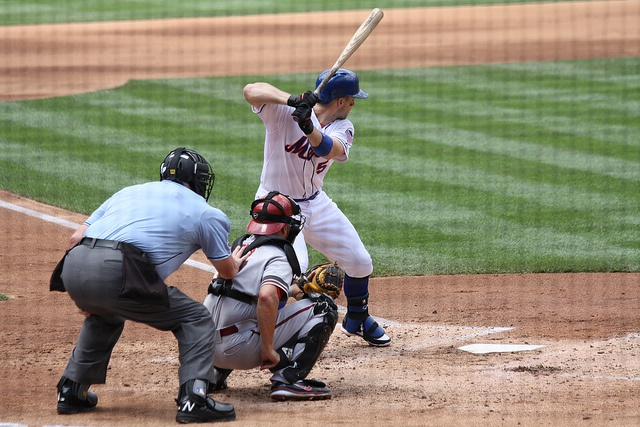Describe the objects in this image and their specific colors. I can see people in olive, black, gray, and lightblue tones, people in olive, black, gray, maroon, and darkgray tones, people in olive, darkgray, black, and lavender tones, baseball glove in olive, black, gray, and maroon tones, and baseball bat in olive, lightgray, tan, darkgray, and gray tones in this image. 